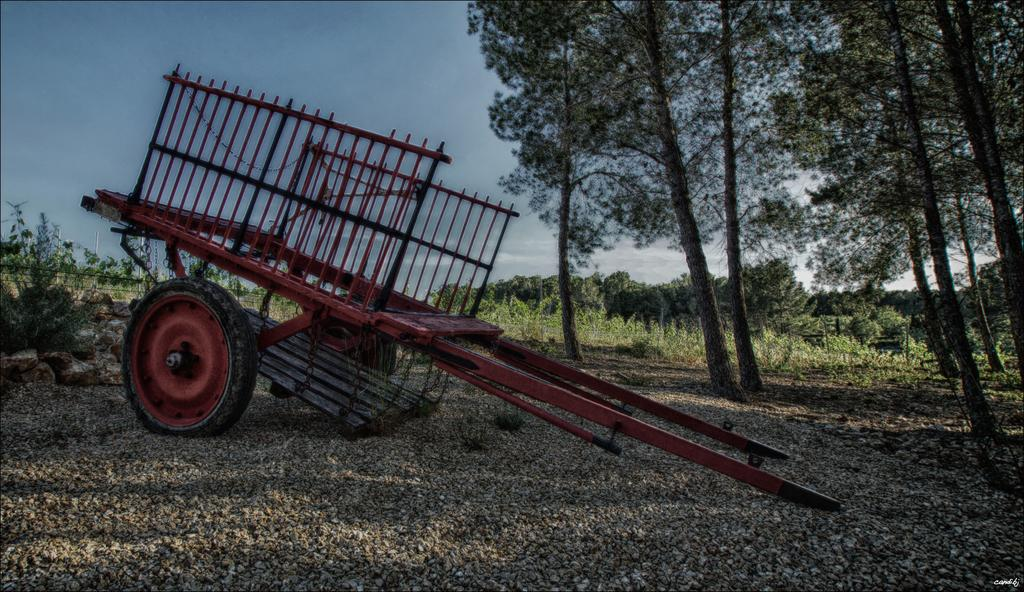What is the main object in the image? There is a cart in the image. Where is the cart located? The cart is on the ground. What can be seen in the background of the image? There are trees and the sky visible in the background of the image. What type of music can be heard coming from the cart in the image? There is no indication in the image that the cart is playing music, so it's not possible to determine what, if any, music might be heard. 